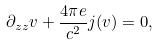<formula> <loc_0><loc_0><loc_500><loc_500>\partial _ { z z } { v } + \frac { 4 \pi e } { c ^ { 2 } } { j ( v ) } = 0 ,</formula> 